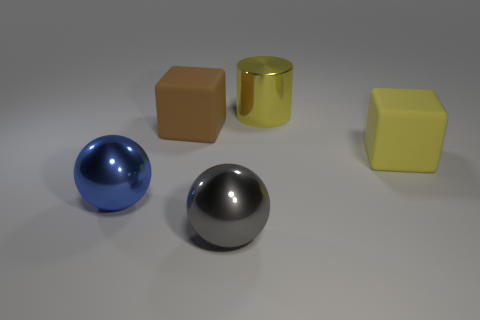Add 1 red rubber cubes. How many objects exist? 6 Subtract all spheres. How many objects are left? 3 Subtract all small brown cylinders. Subtract all brown rubber blocks. How many objects are left? 4 Add 3 yellow cylinders. How many yellow cylinders are left? 4 Add 4 shiny balls. How many shiny balls exist? 6 Subtract 1 blue spheres. How many objects are left? 4 